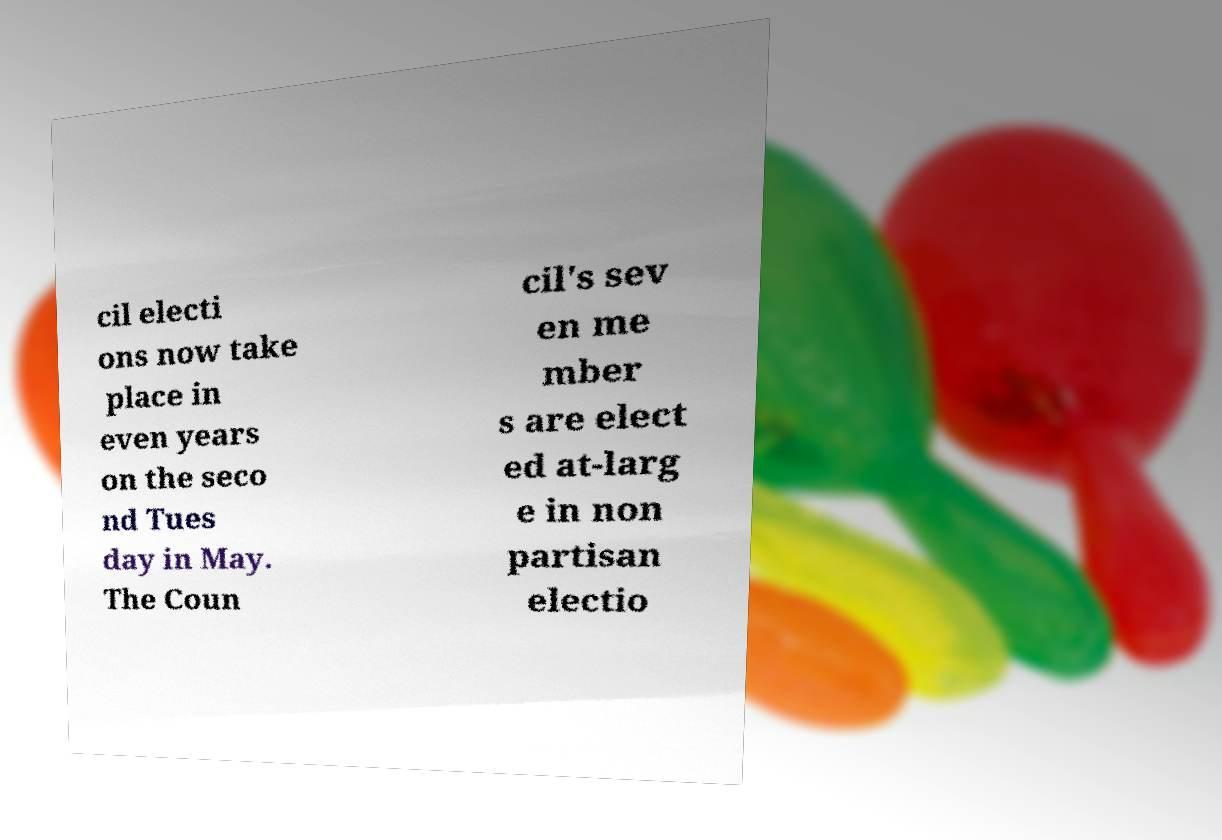What messages or text are displayed in this image? I need them in a readable, typed format. cil electi ons now take place in even years on the seco nd Tues day in May. The Coun cil's sev en me mber s are elect ed at-larg e in non partisan electio 